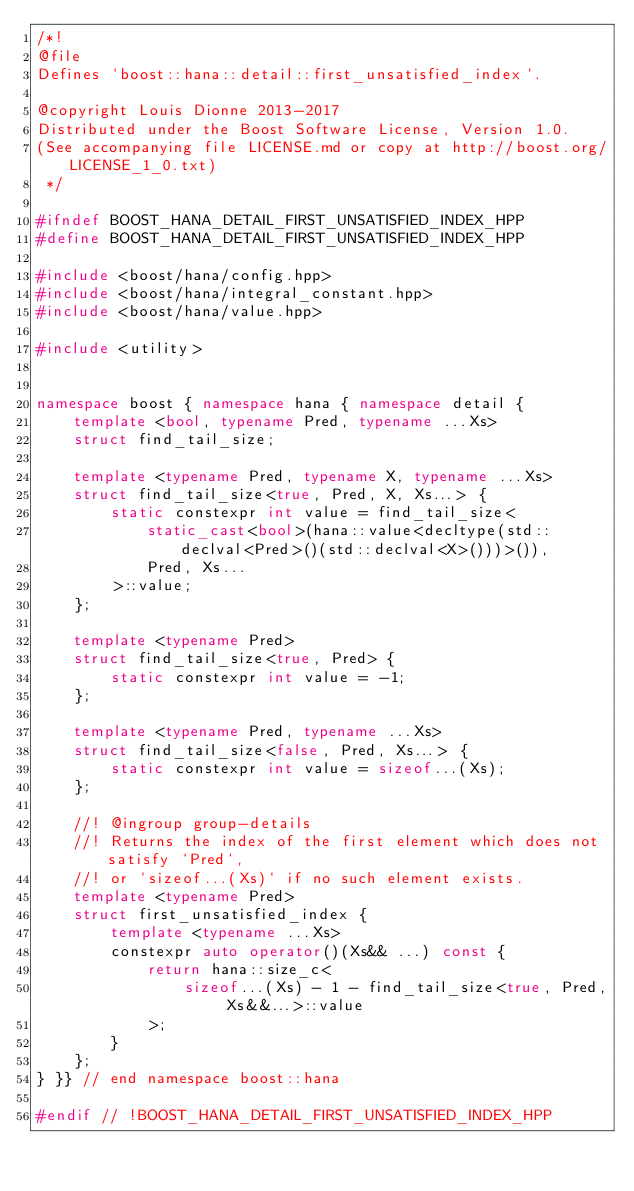<code> <loc_0><loc_0><loc_500><loc_500><_C++_>/*!
@file
Defines `boost::hana::detail::first_unsatisfied_index`.

@copyright Louis Dionne 2013-2017
Distributed under the Boost Software License, Version 1.0.
(See accompanying file LICENSE.md or copy at http://boost.org/LICENSE_1_0.txt)
 */

#ifndef BOOST_HANA_DETAIL_FIRST_UNSATISFIED_INDEX_HPP
#define BOOST_HANA_DETAIL_FIRST_UNSATISFIED_INDEX_HPP

#include <boost/hana/config.hpp>
#include <boost/hana/integral_constant.hpp>
#include <boost/hana/value.hpp>

#include <utility>


namespace boost { namespace hana { namespace detail {
    template <bool, typename Pred, typename ...Xs>
    struct find_tail_size;

    template <typename Pred, typename X, typename ...Xs>
    struct find_tail_size<true, Pred, X, Xs...> {
        static constexpr int value = find_tail_size<
            static_cast<bool>(hana::value<decltype(std::declval<Pred>()(std::declval<X>()))>()),
            Pred, Xs...
        >::value;
    };

    template <typename Pred>
    struct find_tail_size<true, Pred> {
        static constexpr int value = -1;
    };

    template <typename Pred, typename ...Xs>
    struct find_tail_size<false, Pred, Xs...> {
        static constexpr int value = sizeof...(Xs);
    };

    //! @ingroup group-details
    //! Returns the index of the first element which does not satisfy `Pred`,
    //! or `sizeof...(Xs)` if no such element exists.
    template <typename Pred>
    struct first_unsatisfied_index {
        template <typename ...Xs>
        constexpr auto operator()(Xs&& ...) const {
            return hana::size_c<
                sizeof...(Xs) - 1 - find_tail_size<true, Pred, Xs&&...>::value
            >;
        }
    };
} }} // end namespace boost::hana

#endif // !BOOST_HANA_DETAIL_FIRST_UNSATISFIED_INDEX_HPP
</code> 